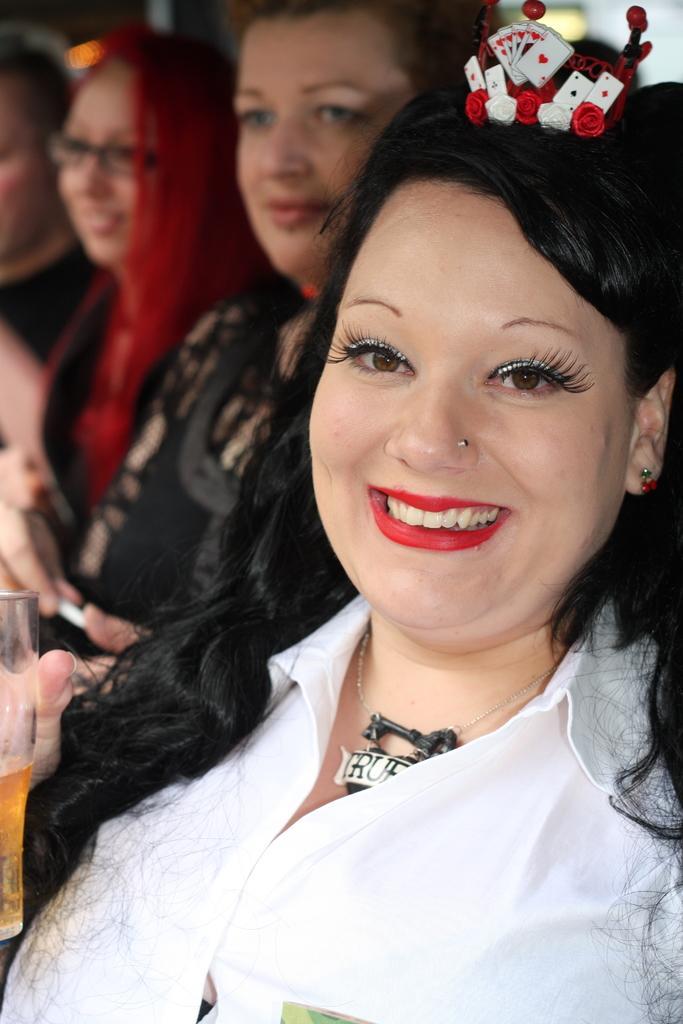Can you describe this image briefly? In the foreground of this image, there is a woman in white shirt having smile on her face is holding a glass and there is a crown on her head. In the background, there are three persons. 